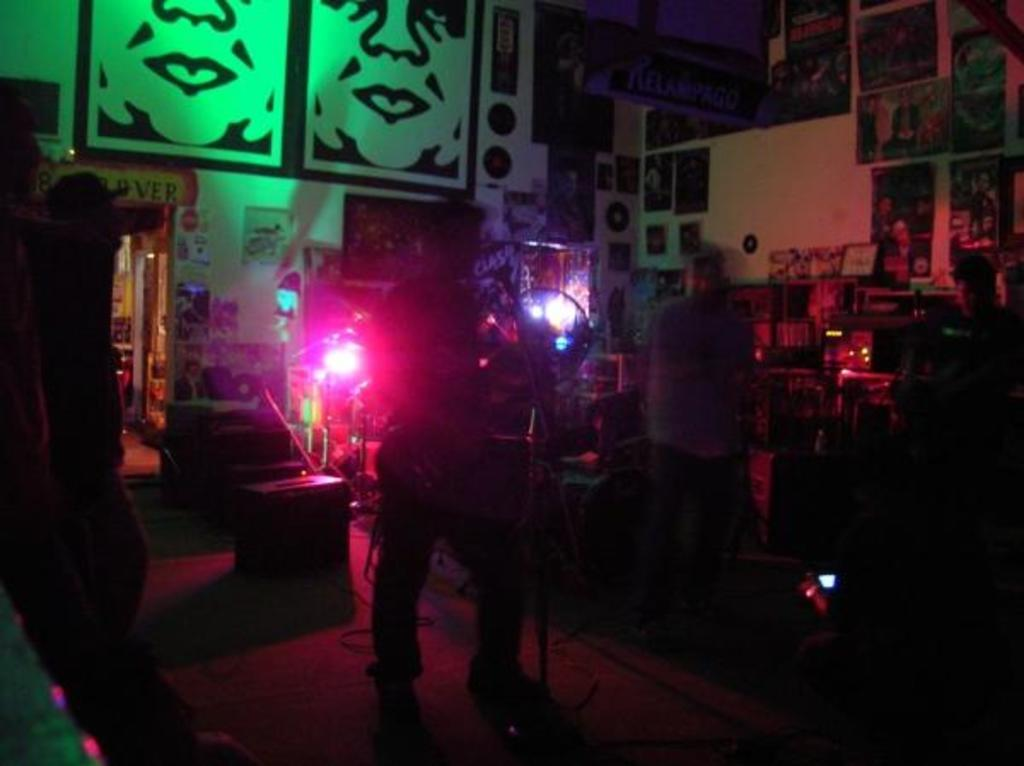How many people are present in the image? There are two persons standing in the image. What can be seen in the background of the image? There is a wall in the background of the image. What is on the wall in the image? There are photo frames on the wall. Can you describe the lighting in the image? There is a light in the image. How many spiders are crawling on the persons in the image? There are no spiders visible in the image; only two persons and a wall with photo frames are present. What season is depicted in the image, considering the presence of falling leaves? There is no indication of falling leaves or a specific season in the image. 